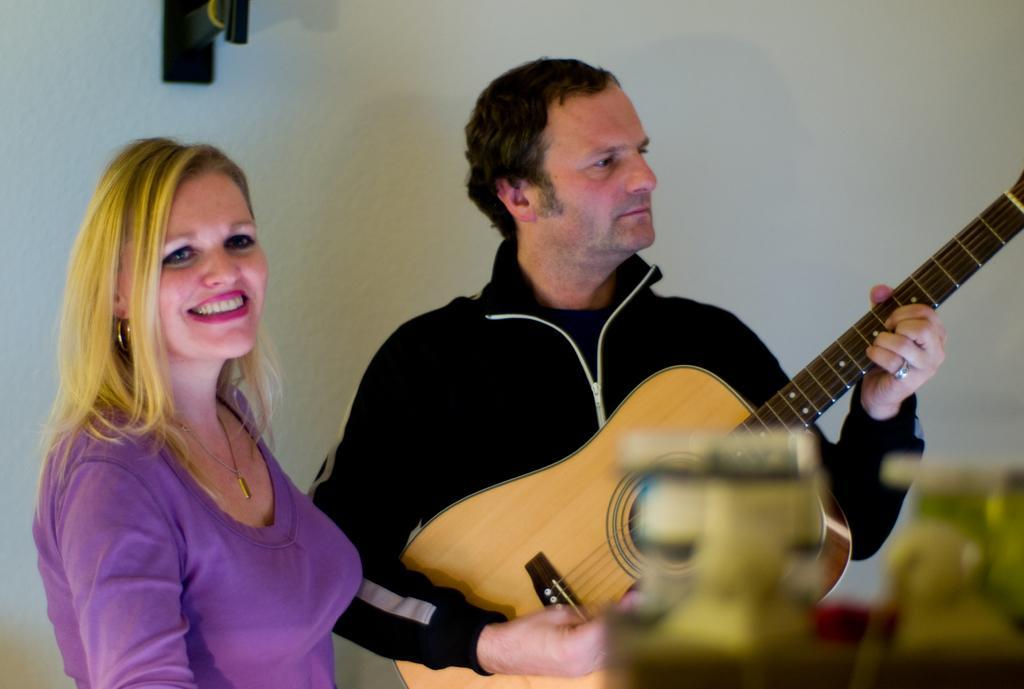Could you give a brief overview of what you see in this image? This picture shows a man playing a guitar and we see a woman standing with a smile on her face 